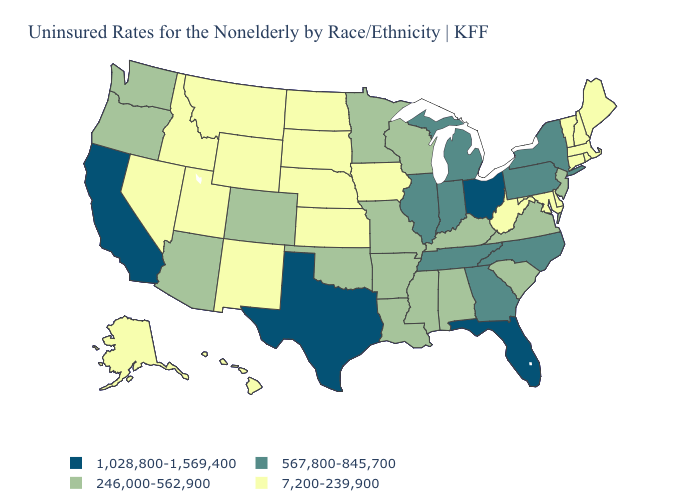Name the states that have a value in the range 567,800-845,700?
Short answer required. Georgia, Illinois, Indiana, Michigan, New York, North Carolina, Pennsylvania, Tennessee. What is the value of Texas?
Concise answer only. 1,028,800-1,569,400. Which states have the highest value in the USA?
Concise answer only. California, Florida, Ohio, Texas. What is the lowest value in the MidWest?
Quick response, please. 7,200-239,900. Which states have the lowest value in the USA?
Be succinct. Alaska, Connecticut, Delaware, Hawaii, Idaho, Iowa, Kansas, Maine, Maryland, Massachusetts, Montana, Nebraska, Nevada, New Hampshire, New Mexico, North Dakota, Rhode Island, South Dakota, Utah, Vermont, West Virginia, Wyoming. Does Missouri have a higher value than South Dakota?
Keep it brief. Yes. Name the states that have a value in the range 7,200-239,900?
Write a very short answer. Alaska, Connecticut, Delaware, Hawaii, Idaho, Iowa, Kansas, Maine, Maryland, Massachusetts, Montana, Nebraska, Nevada, New Hampshire, New Mexico, North Dakota, Rhode Island, South Dakota, Utah, Vermont, West Virginia, Wyoming. What is the value of Minnesota?
Keep it brief. 246,000-562,900. What is the highest value in the Northeast ?
Give a very brief answer. 567,800-845,700. Name the states that have a value in the range 246,000-562,900?
Keep it brief. Alabama, Arizona, Arkansas, Colorado, Kentucky, Louisiana, Minnesota, Mississippi, Missouri, New Jersey, Oklahoma, Oregon, South Carolina, Virginia, Washington, Wisconsin. Name the states that have a value in the range 567,800-845,700?
Short answer required. Georgia, Illinois, Indiana, Michigan, New York, North Carolina, Pennsylvania, Tennessee. Name the states that have a value in the range 7,200-239,900?
Answer briefly. Alaska, Connecticut, Delaware, Hawaii, Idaho, Iowa, Kansas, Maine, Maryland, Massachusetts, Montana, Nebraska, Nevada, New Hampshire, New Mexico, North Dakota, Rhode Island, South Dakota, Utah, Vermont, West Virginia, Wyoming. How many symbols are there in the legend?
Concise answer only. 4. Does California have the highest value in the West?
Give a very brief answer. Yes. 